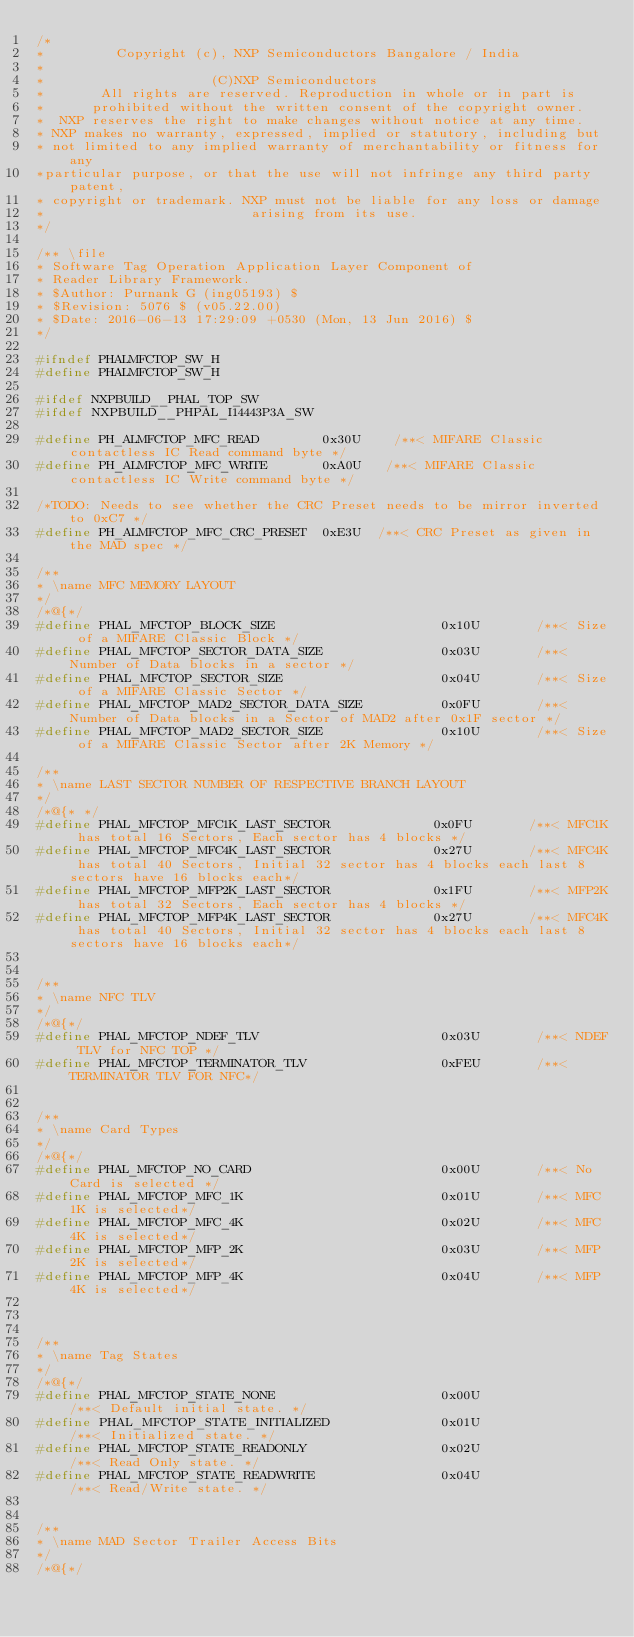Convert code to text. <code><loc_0><loc_0><loc_500><loc_500><_C_>/*
*         Copyright (c), NXP Semiconductors Bangalore / India
*
*                     (C)NXP Semiconductors
*       All rights are reserved. Reproduction in whole or in part is
*      prohibited without the written consent of the copyright owner.
*  NXP reserves the right to make changes without notice at any time.
* NXP makes no warranty, expressed, implied or statutory, including but
* not limited to any implied warranty of merchantability or fitness for any
*particular purpose, or that the use will not infringe any third party patent,
* copyright or trademark. NXP must not be liable for any loss or damage
*                          arising from its use.
*/

/** \file
* Software Tag Operation Application Layer Component of
* Reader Library Framework.
* $Author: Purnank G (ing05193) $
* $Revision: 5076 $ (v05.22.00)
* $Date: 2016-06-13 17:29:09 +0530 (Mon, 13 Jun 2016) $
*/

#ifndef PHALMFCTOP_SW_H
#define PHALMFCTOP_SW_H

#ifdef NXPBUILD__PHAL_TOP_SW
#ifdef NXPBUILD__PHPAL_I14443P3A_SW

#define PH_ALMFCTOP_MFC_READ        0x30U    /**< MIFARE Classic contactless IC Read command byte */
#define PH_ALMFCTOP_MFC_WRITE       0xA0U   /**< MIFARE Classic contactless IC Write command byte */

/*TODO: Needs to see whether the CRC Preset needs to be mirror inverted to 0xC7 */
#define PH_ALMFCTOP_MFC_CRC_PRESET  0xE3U  /**< CRC Preset as given in  the MAD spec */

/**
* \name MFC MEMORY LAYOUT
*/
/*@{*/
#define PHAL_MFCTOP_BLOCK_SIZE                     0x10U       /**< Size of a MIFARE Classic Block */
#define PHAL_MFCTOP_SECTOR_DATA_SIZE               0x03U       /**< Number of Data blocks in a sector */
#define PHAL_MFCTOP_SECTOR_SIZE                    0x04U       /**< Size of a MIFARE Classic Sector */
#define PHAL_MFCTOP_MAD2_SECTOR_DATA_SIZE          0x0FU       /**< Number of Data blocks in a Sector of MAD2 after 0x1F sector */
#define PHAL_MFCTOP_MAD2_SECTOR_SIZE               0x10U       /**< Size of a MIFARE Classic Sector after 2K Memory */

/**
* \name LAST SECTOR NUMBER OF RESPECTIVE BRANCH LAYOUT
*/
/*@{* */
#define PHAL_MFCTOP_MFC1K_LAST_SECTOR             0x0FU       /**< MFC1K has total 16 Sectors, Each sector has 4 blocks */
#define PHAL_MFCTOP_MFC4K_LAST_SECTOR             0x27U       /**< MFC4K has total 40 Sectors, Initial 32 sector has 4 blocks each last 8 sectors have 16 blocks each*/
#define PHAL_MFCTOP_MFP2K_LAST_SECTOR             0x1FU       /**< MFP2K has total 32 Sectors, Each sector has 4 blocks */
#define PHAL_MFCTOP_MFP4K_LAST_SECTOR             0x27U       /**< MFC4K has total 40 Sectors, Initial 32 sector has 4 blocks each last 8 sectors have 16 blocks each*/


/**
* \name NFC TLV
*/
/*@{*/
#define PHAL_MFCTOP_NDEF_TLV                       0x03U       /**< NDEF TLV for NFC TOP */
#define PHAL_MFCTOP_TERMINATOR_TLV                 0xFEU       /**< TERMINATOR TLV FOR NFC*/


/**
* \name Card Types
*/
/*@{*/
#define PHAL_MFCTOP_NO_CARD                        0x00U       /**< No Card is selected */
#define PHAL_MFCTOP_MFC_1K                         0x01U       /**< MFC 1K is selected*/
#define PHAL_MFCTOP_MFC_4K                         0x02U       /**< MFC 4K is selected*/
#define PHAL_MFCTOP_MFP_2K                         0x03U       /**< MFP 2K is selected*/
#define PHAL_MFCTOP_MFP_4K                         0x04U       /**< MFP 4K is selected*/



/**
* \name Tag States
*/
/*@{*/
#define PHAL_MFCTOP_STATE_NONE                     0x00U                /**< Default initial state. */
#define PHAL_MFCTOP_STATE_INITIALIZED              0x01U                /**< Initialized state. */
#define PHAL_MFCTOP_STATE_READONLY                 0x02U                /**< Read Only state. */
#define PHAL_MFCTOP_STATE_READWRITE                0x04U                /**< Read/Write state. */


/**
* \name MAD Sector Trailer Access Bits
*/
/*@{*/
</code> 